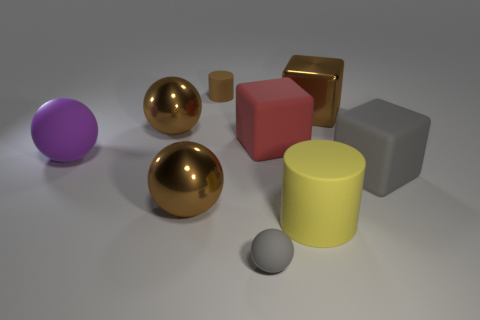What number of big red rubber things have the same shape as the small brown object?
Offer a very short reply. 0. Do the tiny cylinder and the tiny rubber sphere have the same color?
Give a very brief answer. No. Are there any other things that are the same shape as the brown rubber object?
Give a very brief answer. Yes. Is there a metal cylinder that has the same color as the big rubber sphere?
Give a very brief answer. No. Are the cylinder that is behind the big brown block and the large brown block that is right of the purple matte ball made of the same material?
Give a very brief answer. No. The shiny block has what color?
Provide a short and direct response. Brown. What size is the rubber thing behind the brown metallic object that is to the right of the cylinder on the left side of the gray sphere?
Your response must be concise. Small. How many other things are there of the same size as the red rubber block?
Make the answer very short. 6. How many small objects are the same material as the large red thing?
Provide a succinct answer. 2. The matte object to the left of the brown rubber thing has what shape?
Your answer should be compact. Sphere. 